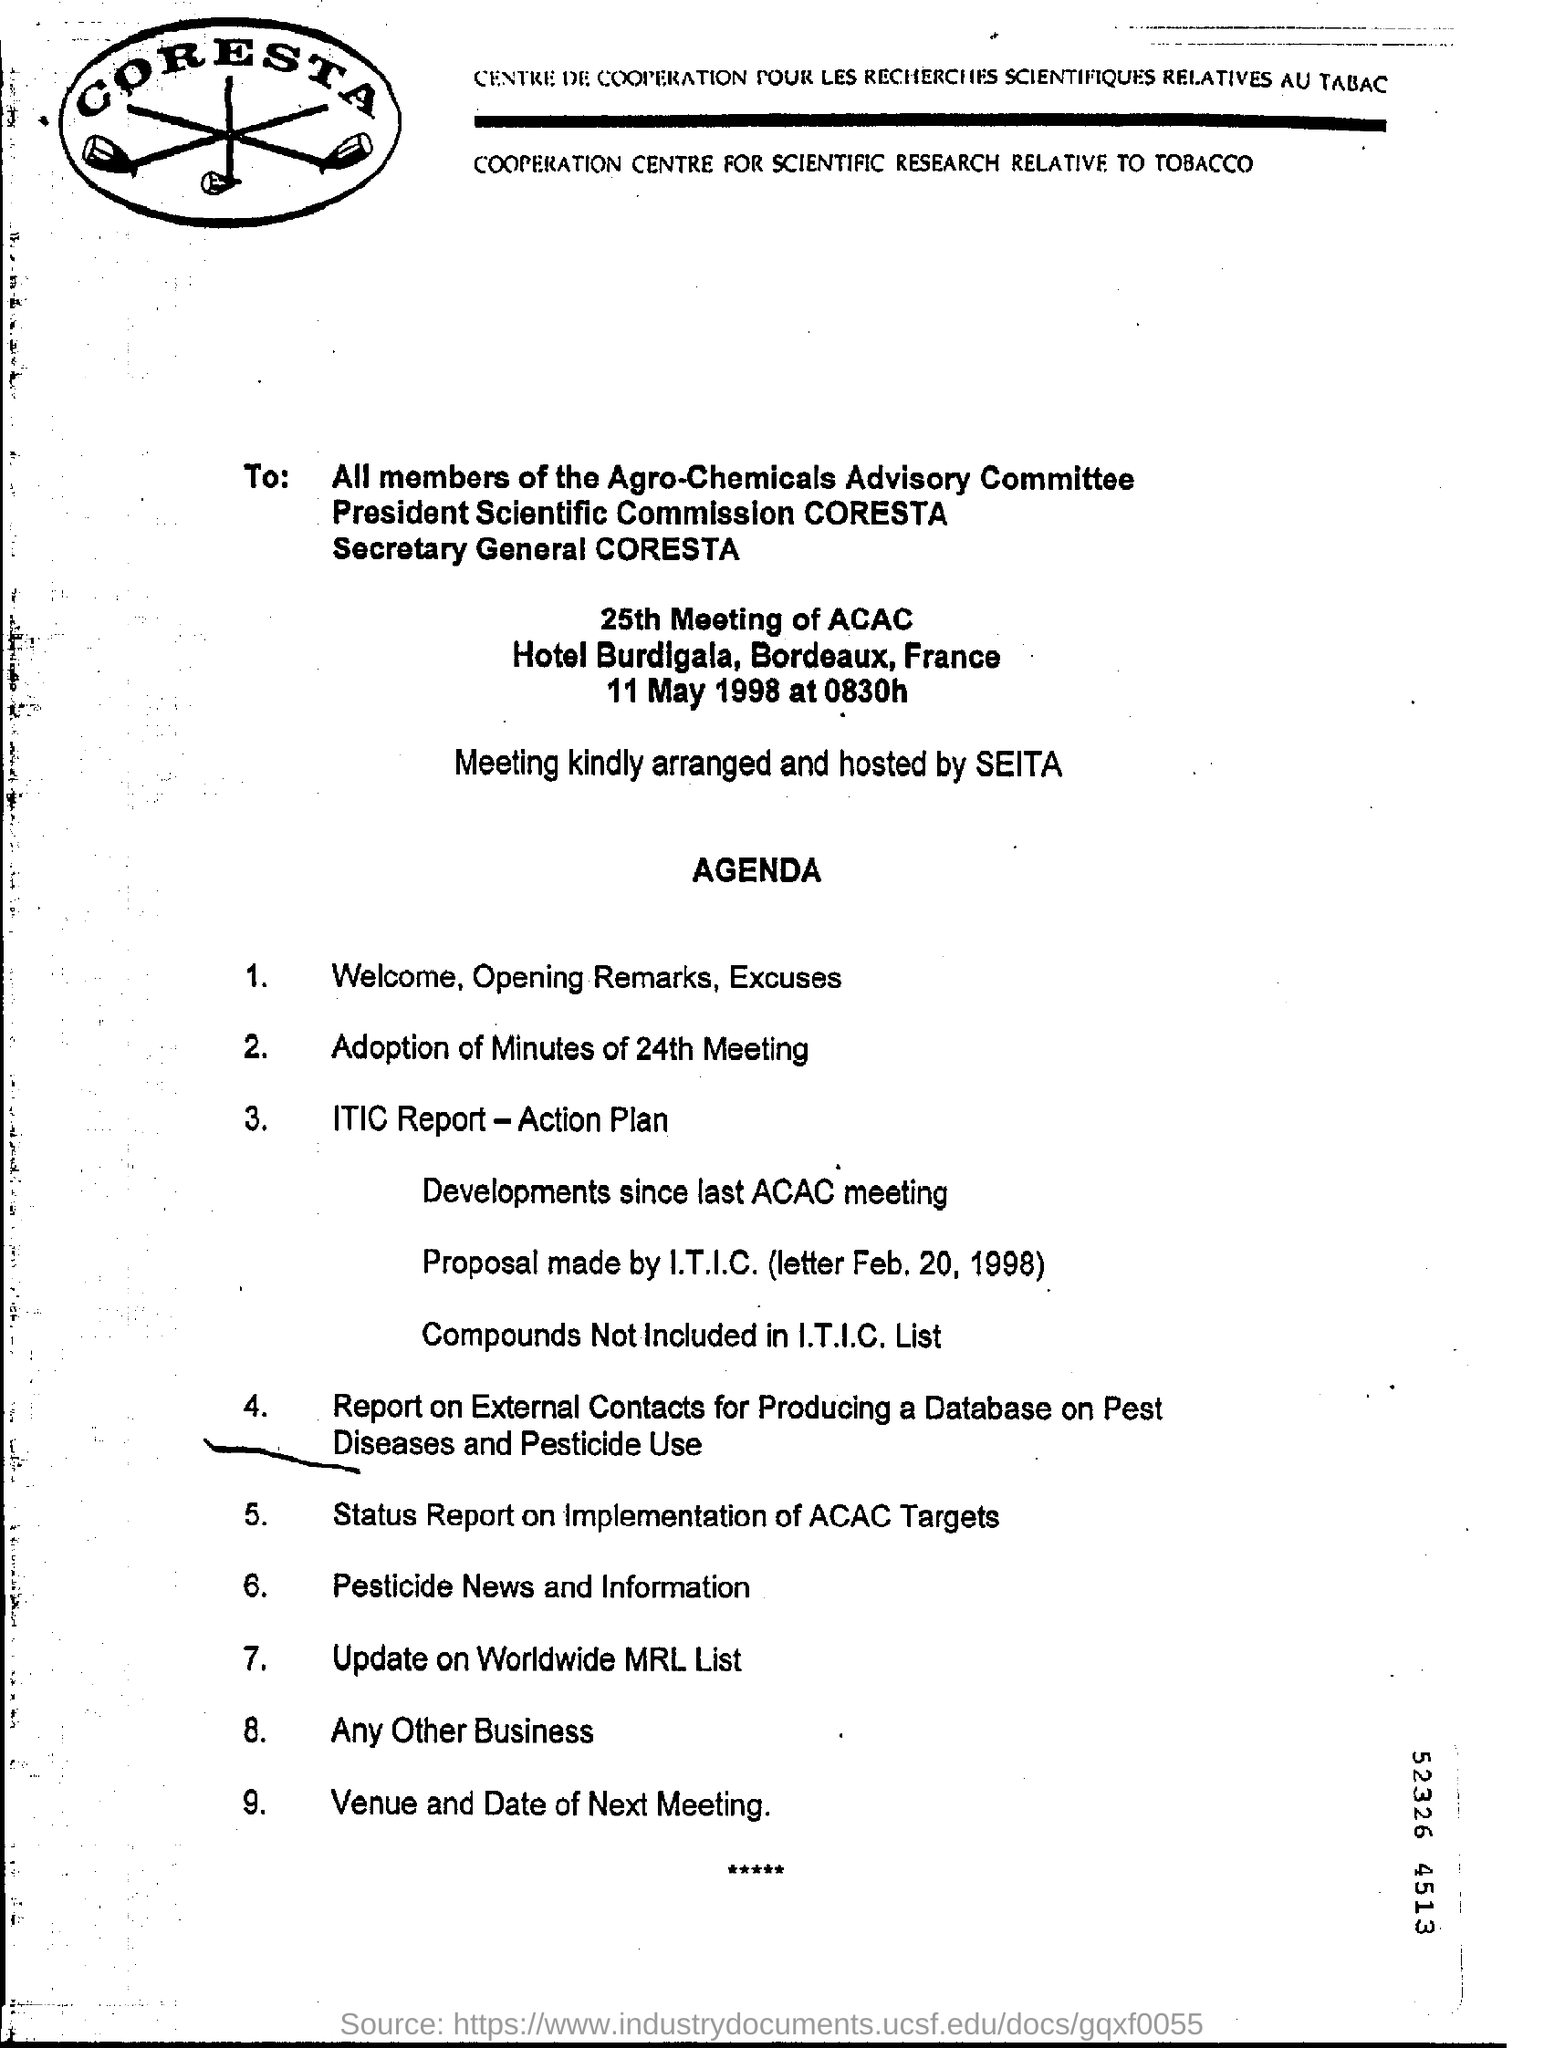By whom is the meeting arranged and hosted?
Provide a succinct answer. SEITA. 